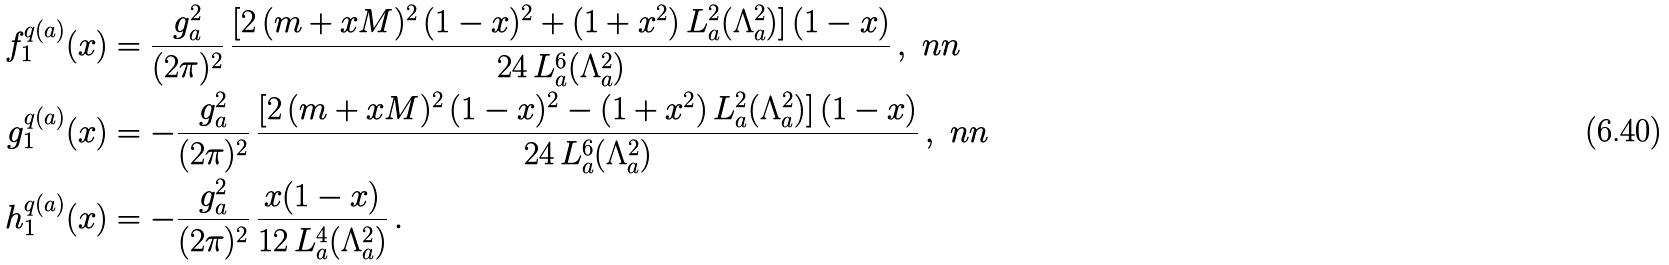Convert formula to latex. <formula><loc_0><loc_0><loc_500><loc_500>f _ { 1 } ^ { q ( a ) } ( x ) & = \frac { g _ { a } ^ { 2 } } { ( 2 \pi ) ^ { 2 } } \, \frac { [ 2 \, ( m + x M ) ^ { 2 } \, ( 1 - x ) ^ { 2 } + ( 1 + x ^ { 2 } ) \, L _ { a } ^ { 2 } ( \Lambda _ { a } ^ { 2 } ) ] \, ( 1 - x ) } { 2 4 \, L _ { a } ^ { 6 } ( \Lambda _ { a } ^ { 2 } ) } \, , \ n n \\ g _ { 1 } ^ { q ( a ) } ( x ) & = - \frac { g _ { a } ^ { 2 } } { ( 2 \pi ) ^ { 2 } } \, \frac { [ 2 \, ( m + x M ) ^ { 2 } \, ( 1 - x ) ^ { 2 } - ( 1 + x ^ { 2 } ) \, L _ { a } ^ { 2 } ( \Lambda _ { a } ^ { 2 } ) ] \, ( 1 - x ) } { 2 4 \, L _ { a } ^ { 6 } ( \Lambda _ { a } ^ { 2 } ) } \, , \ n n \\ h _ { 1 } ^ { q ( a ) } ( x ) & = - \frac { g _ { a } ^ { 2 } } { ( 2 \pi ) ^ { 2 } } \, \frac { x ( 1 - x ) } { 1 2 \, L _ { a } ^ { 4 } ( \Lambda _ { a } ^ { 2 } ) } \, .</formula> 